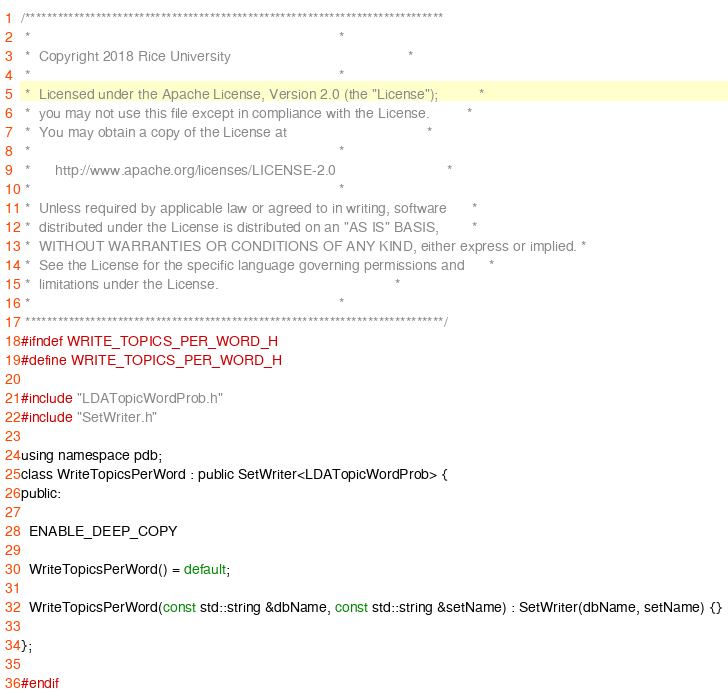<code> <loc_0><loc_0><loc_500><loc_500><_C_>/*****************************************************************************
 *                                                                           *
 *  Copyright 2018 Rice University                                           *
 *                                                                           *
 *  Licensed under the Apache License, Version 2.0 (the "License");          *
 *  you may not use this file except in compliance with the License.         *
 *  You may obtain a copy of the License at                                  *
 *                                                                           *
 *      http://www.apache.org/licenses/LICENSE-2.0                           *
 *                                                                           *
 *  Unless required by applicable law or agreed to in writing, software      *
 *  distributed under the License is distributed on an "AS IS" BASIS,        *
 *  WITHOUT WARRANTIES OR CONDITIONS OF ANY KIND, either express or implied. *
 *  See the License for the specific language governing permissions and      *
 *  limitations under the License.                                           *
 *                                                                           *
 *****************************************************************************/
#ifndef WRITE_TOPICS_PER_WORD_H
#define WRITE_TOPICS_PER_WORD_H

#include "LDATopicWordProb.h"
#include "SetWriter.h"

using namespace pdb;
class WriteTopicsPerWord : public SetWriter<LDATopicWordProb> {
public:

  ENABLE_DEEP_COPY

  WriteTopicsPerWord() = default;

  WriteTopicsPerWord(const std::string &dbName, const std::string &setName) : SetWriter(dbName, setName) {}

};

#endif
</code> 